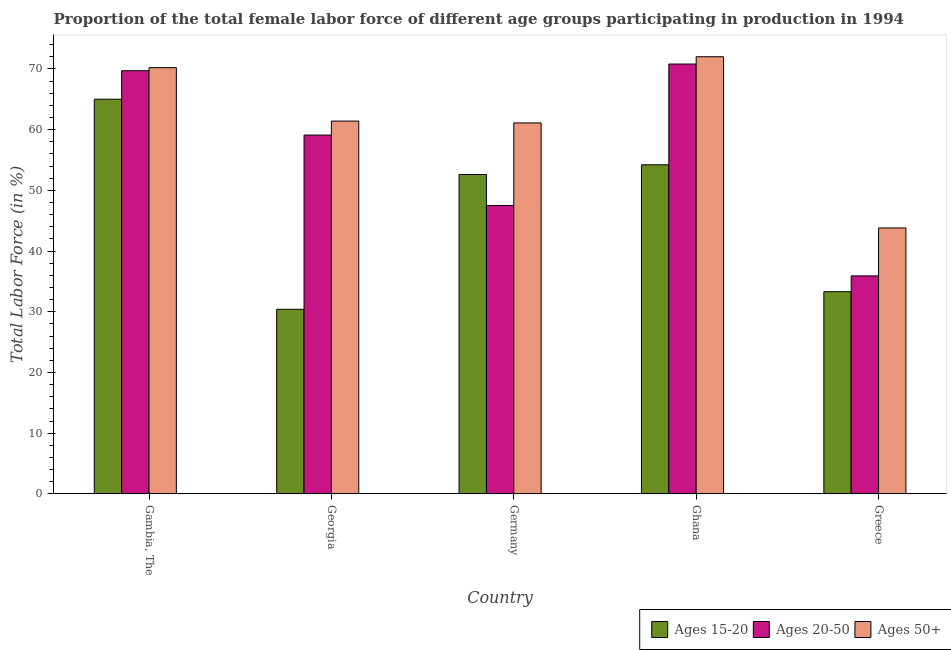How many different coloured bars are there?
Make the answer very short. 3. Are the number of bars on each tick of the X-axis equal?
Offer a terse response. Yes. How many bars are there on the 2nd tick from the left?
Give a very brief answer. 3. What is the label of the 4th group of bars from the left?
Ensure brevity in your answer.  Ghana. In how many cases, is the number of bars for a given country not equal to the number of legend labels?
Give a very brief answer. 0. What is the percentage of female labor force within the age group 20-50 in Greece?
Your response must be concise. 35.9. Across all countries, what is the minimum percentage of female labor force within the age group 20-50?
Your answer should be very brief. 35.9. In which country was the percentage of female labor force above age 50 maximum?
Your answer should be very brief. Ghana. What is the total percentage of female labor force within the age group 15-20 in the graph?
Your answer should be very brief. 235.5. What is the difference between the percentage of female labor force within the age group 15-20 in Ghana and that in Greece?
Your answer should be compact. 20.9. What is the difference between the percentage of female labor force within the age group 15-20 in Germany and the percentage of female labor force within the age group 20-50 in Greece?
Give a very brief answer. 16.7. What is the average percentage of female labor force above age 50 per country?
Offer a very short reply. 61.7. What is the ratio of the percentage of female labor force within the age group 20-50 in Georgia to that in Greece?
Your answer should be compact. 1.65. Is the percentage of female labor force within the age group 20-50 in Gambia, The less than that in Ghana?
Your answer should be very brief. Yes. What is the difference between the highest and the second highest percentage of female labor force within the age group 20-50?
Your answer should be very brief. 1.1. What is the difference between the highest and the lowest percentage of female labor force within the age group 20-50?
Offer a terse response. 34.9. In how many countries, is the percentage of female labor force within the age group 15-20 greater than the average percentage of female labor force within the age group 15-20 taken over all countries?
Provide a succinct answer. 3. Is the sum of the percentage of female labor force within the age group 15-20 in Georgia and Ghana greater than the maximum percentage of female labor force within the age group 20-50 across all countries?
Your answer should be compact. Yes. What does the 1st bar from the left in Greece represents?
Offer a very short reply. Ages 15-20. What does the 1st bar from the right in Greece represents?
Provide a short and direct response. Ages 50+. Are all the bars in the graph horizontal?
Offer a very short reply. No. How many countries are there in the graph?
Make the answer very short. 5. What is the difference between two consecutive major ticks on the Y-axis?
Provide a succinct answer. 10. Are the values on the major ticks of Y-axis written in scientific E-notation?
Your answer should be compact. No. Where does the legend appear in the graph?
Give a very brief answer. Bottom right. How many legend labels are there?
Your response must be concise. 3. How are the legend labels stacked?
Provide a succinct answer. Horizontal. What is the title of the graph?
Offer a very short reply. Proportion of the total female labor force of different age groups participating in production in 1994. What is the label or title of the X-axis?
Your response must be concise. Country. What is the label or title of the Y-axis?
Your answer should be very brief. Total Labor Force (in %). What is the Total Labor Force (in %) of Ages 15-20 in Gambia, The?
Provide a short and direct response. 65. What is the Total Labor Force (in %) in Ages 20-50 in Gambia, The?
Offer a terse response. 69.7. What is the Total Labor Force (in %) of Ages 50+ in Gambia, The?
Provide a short and direct response. 70.2. What is the Total Labor Force (in %) in Ages 15-20 in Georgia?
Provide a short and direct response. 30.4. What is the Total Labor Force (in %) in Ages 20-50 in Georgia?
Provide a succinct answer. 59.1. What is the Total Labor Force (in %) of Ages 50+ in Georgia?
Your answer should be very brief. 61.4. What is the Total Labor Force (in %) of Ages 15-20 in Germany?
Your answer should be very brief. 52.6. What is the Total Labor Force (in %) of Ages 20-50 in Germany?
Provide a succinct answer. 47.5. What is the Total Labor Force (in %) of Ages 50+ in Germany?
Your answer should be very brief. 61.1. What is the Total Labor Force (in %) of Ages 15-20 in Ghana?
Offer a terse response. 54.2. What is the Total Labor Force (in %) of Ages 20-50 in Ghana?
Ensure brevity in your answer.  70.8. What is the Total Labor Force (in %) in Ages 15-20 in Greece?
Offer a terse response. 33.3. What is the Total Labor Force (in %) in Ages 20-50 in Greece?
Provide a short and direct response. 35.9. What is the Total Labor Force (in %) of Ages 50+ in Greece?
Make the answer very short. 43.8. Across all countries, what is the maximum Total Labor Force (in %) in Ages 15-20?
Give a very brief answer. 65. Across all countries, what is the maximum Total Labor Force (in %) of Ages 20-50?
Keep it short and to the point. 70.8. Across all countries, what is the maximum Total Labor Force (in %) in Ages 50+?
Offer a very short reply. 72. Across all countries, what is the minimum Total Labor Force (in %) in Ages 15-20?
Offer a very short reply. 30.4. Across all countries, what is the minimum Total Labor Force (in %) in Ages 20-50?
Provide a short and direct response. 35.9. Across all countries, what is the minimum Total Labor Force (in %) of Ages 50+?
Offer a very short reply. 43.8. What is the total Total Labor Force (in %) in Ages 15-20 in the graph?
Ensure brevity in your answer.  235.5. What is the total Total Labor Force (in %) of Ages 20-50 in the graph?
Offer a very short reply. 283. What is the total Total Labor Force (in %) of Ages 50+ in the graph?
Make the answer very short. 308.5. What is the difference between the Total Labor Force (in %) of Ages 15-20 in Gambia, The and that in Georgia?
Give a very brief answer. 34.6. What is the difference between the Total Labor Force (in %) in Ages 50+ in Gambia, The and that in Georgia?
Your answer should be compact. 8.8. What is the difference between the Total Labor Force (in %) in Ages 15-20 in Gambia, The and that in Germany?
Give a very brief answer. 12.4. What is the difference between the Total Labor Force (in %) in Ages 15-20 in Gambia, The and that in Ghana?
Offer a terse response. 10.8. What is the difference between the Total Labor Force (in %) in Ages 15-20 in Gambia, The and that in Greece?
Your answer should be compact. 31.7. What is the difference between the Total Labor Force (in %) of Ages 20-50 in Gambia, The and that in Greece?
Your answer should be compact. 33.8. What is the difference between the Total Labor Force (in %) of Ages 50+ in Gambia, The and that in Greece?
Your response must be concise. 26.4. What is the difference between the Total Labor Force (in %) of Ages 15-20 in Georgia and that in Germany?
Offer a terse response. -22.2. What is the difference between the Total Labor Force (in %) of Ages 15-20 in Georgia and that in Ghana?
Provide a short and direct response. -23.8. What is the difference between the Total Labor Force (in %) of Ages 50+ in Georgia and that in Ghana?
Make the answer very short. -10.6. What is the difference between the Total Labor Force (in %) in Ages 20-50 in Georgia and that in Greece?
Provide a succinct answer. 23.2. What is the difference between the Total Labor Force (in %) in Ages 50+ in Georgia and that in Greece?
Offer a very short reply. 17.6. What is the difference between the Total Labor Force (in %) in Ages 20-50 in Germany and that in Ghana?
Provide a short and direct response. -23.3. What is the difference between the Total Labor Force (in %) of Ages 50+ in Germany and that in Ghana?
Make the answer very short. -10.9. What is the difference between the Total Labor Force (in %) in Ages 15-20 in Germany and that in Greece?
Ensure brevity in your answer.  19.3. What is the difference between the Total Labor Force (in %) of Ages 15-20 in Ghana and that in Greece?
Offer a terse response. 20.9. What is the difference between the Total Labor Force (in %) of Ages 20-50 in Ghana and that in Greece?
Offer a very short reply. 34.9. What is the difference between the Total Labor Force (in %) in Ages 50+ in Ghana and that in Greece?
Your answer should be very brief. 28.2. What is the difference between the Total Labor Force (in %) in Ages 15-20 in Gambia, The and the Total Labor Force (in %) in Ages 50+ in Georgia?
Provide a short and direct response. 3.6. What is the difference between the Total Labor Force (in %) of Ages 15-20 in Gambia, The and the Total Labor Force (in %) of Ages 20-50 in Germany?
Your response must be concise. 17.5. What is the difference between the Total Labor Force (in %) in Ages 15-20 in Gambia, The and the Total Labor Force (in %) in Ages 50+ in Germany?
Offer a very short reply. 3.9. What is the difference between the Total Labor Force (in %) of Ages 15-20 in Gambia, The and the Total Labor Force (in %) of Ages 20-50 in Ghana?
Provide a succinct answer. -5.8. What is the difference between the Total Labor Force (in %) of Ages 15-20 in Gambia, The and the Total Labor Force (in %) of Ages 50+ in Ghana?
Ensure brevity in your answer.  -7. What is the difference between the Total Labor Force (in %) of Ages 15-20 in Gambia, The and the Total Labor Force (in %) of Ages 20-50 in Greece?
Your response must be concise. 29.1. What is the difference between the Total Labor Force (in %) of Ages 15-20 in Gambia, The and the Total Labor Force (in %) of Ages 50+ in Greece?
Your response must be concise. 21.2. What is the difference between the Total Labor Force (in %) of Ages 20-50 in Gambia, The and the Total Labor Force (in %) of Ages 50+ in Greece?
Your response must be concise. 25.9. What is the difference between the Total Labor Force (in %) of Ages 15-20 in Georgia and the Total Labor Force (in %) of Ages 20-50 in Germany?
Your response must be concise. -17.1. What is the difference between the Total Labor Force (in %) of Ages 15-20 in Georgia and the Total Labor Force (in %) of Ages 50+ in Germany?
Keep it short and to the point. -30.7. What is the difference between the Total Labor Force (in %) of Ages 15-20 in Georgia and the Total Labor Force (in %) of Ages 20-50 in Ghana?
Offer a terse response. -40.4. What is the difference between the Total Labor Force (in %) of Ages 15-20 in Georgia and the Total Labor Force (in %) of Ages 50+ in Ghana?
Keep it short and to the point. -41.6. What is the difference between the Total Labor Force (in %) of Ages 20-50 in Georgia and the Total Labor Force (in %) of Ages 50+ in Ghana?
Keep it short and to the point. -12.9. What is the difference between the Total Labor Force (in %) in Ages 15-20 in Georgia and the Total Labor Force (in %) in Ages 50+ in Greece?
Give a very brief answer. -13.4. What is the difference between the Total Labor Force (in %) of Ages 20-50 in Georgia and the Total Labor Force (in %) of Ages 50+ in Greece?
Offer a terse response. 15.3. What is the difference between the Total Labor Force (in %) of Ages 15-20 in Germany and the Total Labor Force (in %) of Ages 20-50 in Ghana?
Your answer should be compact. -18.2. What is the difference between the Total Labor Force (in %) in Ages 15-20 in Germany and the Total Labor Force (in %) in Ages 50+ in Ghana?
Offer a very short reply. -19.4. What is the difference between the Total Labor Force (in %) in Ages 20-50 in Germany and the Total Labor Force (in %) in Ages 50+ in Ghana?
Provide a short and direct response. -24.5. What is the difference between the Total Labor Force (in %) in Ages 15-20 in Germany and the Total Labor Force (in %) in Ages 20-50 in Greece?
Your answer should be compact. 16.7. What is the difference between the Total Labor Force (in %) in Ages 20-50 in Germany and the Total Labor Force (in %) in Ages 50+ in Greece?
Your response must be concise. 3.7. What is the difference between the Total Labor Force (in %) in Ages 20-50 in Ghana and the Total Labor Force (in %) in Ages 50+ in Greece?
Offer a very short reply. 27. What is the average Total Labor Force (in %) of Ages 15-20 per country?
Make the answer very short. 47.1. What is the average Total Labor Force (in %) in Ages 20-50 per country?
Keep it short and to the point. 56.6. What is the average Total Labor Force (in %) of Ages 50+ per country?
Your answer should be very brief. 61.7. What is the difference between the Total Labor Force (in %) in Ages 15-20 and Total Labor Force (in %) in Ages 20-50 in Gambia, The?
Your response must be concise. -4.7. What is the difference between the Total Labor Force (in %) of Ages 15-20 and Total Labor Force (in %) of Ages 20-50 in Georgia?
Make the answer very short. -28.7. What is the difference between the Total Labor Force (in %) of Ages 15-20 and Total Labor Force (in %) of Ages 50+ in Georgia?
Offer a terse response. -31. What is the difference between the Total Labor Force (in %) in Ages 15-20 and Total Labor Force (in %) in Ages 20-50 in Germany?
Ensure brevity in your answer.  5.1. What is the difference between the Total Labor Force (in %) in Ages 15-20 and Total Labor Force (in %) in Ages 50+ in Germany?
Offer a very short reply. -8.5. What is the difference between the Total Labor Force (in %) in Ages 20-50 and Total Labor Force (in %) in Ages 50+ in Germany?
Offer a very short reply. -13.6. What is the difference between the Total Labor Force (in %) of Ages 15-20 and Total Labor Force (in %) of Ages 20-50 in Ghana?
Offer a terse response. -16.6. What is the difference between the Total Labor Force (in %) of Ages 15-20 and Total Labor Force (in %) of Ages 50+ in Ghana?
Give a very brief answer. -17.8. What is the difference between the Total Labor Force (in %) of Ages 20-50 and Total Labor Force (in %) of Ages 50+ in Ghana?
Give a very brief answer. -1.2. What is the difference between the Total Labor Force (in %) of Ages 15-20 and Total Labor Force (in %) of Ages 20-50 in Greece?
Your answer should be very brief. -2.6. What is the difference between the Total Labor Force (in %) of Ages 15-20 and Total Labor Force (in %) of Ages 50+ in Greece?
Keep it short and to the point. -10.5. What is the ratio of the Total Labor Force (in %) in Ages 15-20 in Gambia, The to that in Georgia?
Make the answer very short. 2.14. What is the ratio of the Total Labor Force (in %) in Ages 20-50 in Gambia, The to that in Georgia?
Your answer should be compact. 1.18. What is the ratio of the Total Labor Force (in %) in Ages 50+ in Gambia, The to that in Georgia?
Provide a short and direct response. 1.14. What is the ratio of the Total Labor Force (in %) of Ages 15-20 in Gambia, The to that in Germany?
Your answer should be very brief. 1.24. What is the ratio of the Total Labor Force (in %) of Ages 20-50 in Gambia, The to that in Germany?
Offer a very short reply. 1.47. What is the ratio of the Total Labor Force (in %) of Ages 50+ in Gambia, The to that in Germany?
Offer a terse response. 1.15. What is the ratio of the Total Labor Force (in %) of Ages 15-20 in Gambia, The to that in Ghana?
Provide a short and direct response. 1.2. What is the ratio of the Total Labor Force (in %) of Ages 20-50 in Gambia, The to that in Ghana?
Your answer should be very brief. 0.98. What is the ratio of the Total Labor Force (in %) of Ages 15-20 in Gambia, The to that in Greece?
Your answer should be compact. 1.95. What is the ratio of the Total Labor Force (in %) of Ages 20-50 in Gambia, The to that in Greece?
Give a very brief answer. 1.94. What is the ratio of the Total Labor Force (in %) in Ages 50+ in Gambia, The to that in Greece?
Your response must be concise. 1.6. What is the ratio of the Total Labor Force (in %) in Ages 15-20 in Georgia to that in Germany?
Offer a very short reply. 0.58. What is the ratio of the Total Labor Force (in %) in Ages 20-50 in Georgia to that in Germany?
Offer a terse response. 1.24. What is the ratio of the Total Labor Force (in %) in Ages 50+ in Georgia to that in Germany?
Offer a very short reply. 1. What is the ratio of the Total Labor Force (in %) in Ages 15-20 in Georgia to that in Ghana?
Provide a succinct answer. 0.56. What is the ratio of the Total Labor Force (in %) of Ages 20-50 in Georgia to that in Ghana?
Your answer should be very brief. 0.83. What is the ratio of the Total Labor Force (in %) of Ages 50+ in Georgia to that in Ghana?
Keep it short and to the point. 0.85. What is the ratio of the Total Labor Force (in %) of Ages 15-20 in Georgia to that in Greece?
Your answer should be compact. 0.91. What is the ratio of the Total Labor Force (in %) of Ages 20-50 in Georgia to that in Greece?
Your answer should be compact. 1.65. What is the ratio of the Total Labor Force (in %) in Ages 50+ in Georgia to that in Greece?
Your answer should be very brief. 1.4. What is the ratio of the Total Labor Force (in %) in Ages 15-20 in Germany to that in Ghana?
Ensure brevity in your answer.  0.97. What is the ratio of the Total Labor Force (in %) of Ages 20-50 in Germany to that in Ghana?
Provide a succinct answer. 0.67. What is the ratio of the Total Labor Force (in %) in Ages 50+ in Germany to that in Ghana?
Give a very brief answer. 0.85. What is the ratio of the Total Labor Force (in %) of Ages 15-20 in Germany to that in Greece?
Your response must be concise. 1.58. What is the ratio of the Total Labor Force (in %) in Ages 20-50 in Germany to that in Greece?
Keep it short and to the point. 1.32. What is the ratio of the Total Labor Force (in %) of Ages 50+ in Germany to that in Greece?
Ensure brevity in your answer.  1.4. What is the ratio of the Total Labor Force (in %) of Ages 15-20 in Ghana to that in Greece?
Make the answer very short. 1.63. What is the ratio of the Total Labor Force (in %) in Ages 20-50 in Ghana to that in Greece?
Your answer should be very brief. 1.97. What is the ratio of the Total Labor Force (in %) of Ages 50+ in Ghana to that in Greece?
Give a very brief answer. 1.64. What is the difference between the highest and the second highest Total Labor Force (in %) of Ages 15-20?
Provide a short and direct response. 10.8. What is the difference between the highest and the second highest Total Labor Force (in %) in Ages 20-50?
Keep it short and to the point. 1.1. What is the difference between the highest and the lowest Total Labor Force (in %) in Ages 15-20?
Offer a very short reply. 34.6. What is the difference between the highest and the lowest Total Labor Force (in %) of Ages 20-50?
Provide a short and direct response. 34.9. What is the difference between the highest and the lowest Total Labor Force (in %) in Ages 50+?
Provide a short and direct response. 28.2. 